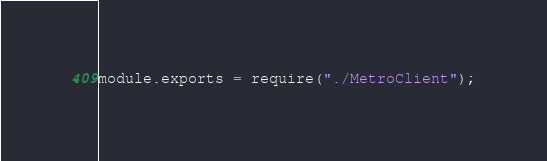Convert code to text. <code><loc_0><loc_0><loc_500><loc_500><_JavaScript_>
module.exports = require("./MetroClient");
</code> 